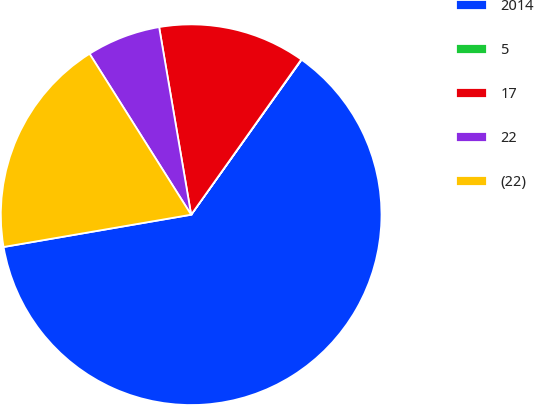<chart> <loc_0><loc_0><loc_500><loc_500><pie_chart><fcel>2014<fcel>5<fcel>17<fcel>22<fcel>(22)<nl><fcel>62.43%<fcel>0.03%<fcel>12.51%<fcel>6.27%<fcel>18.75%<nl></chart> 